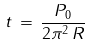Convert formula to latex. <formula><loc_0><loc_0><loc_500><loc_500>t \, = \, \frac { P _ { 0 } } { 2 \pi ^ { 2 } \, R }</formula> 